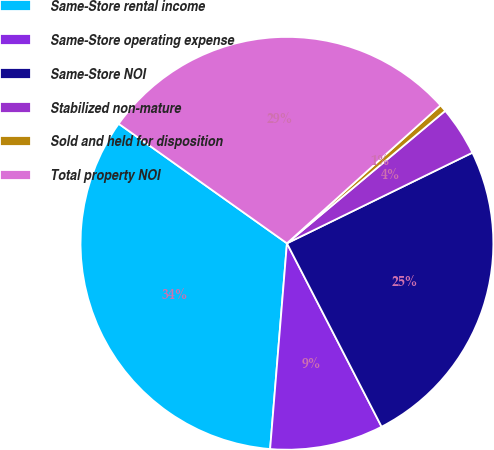Convert chart. <chart><loc_0><loc_0><loc_500><loc_500><pie_chart><fcel>Same-Store rental income<fcel>Same-Store operating expense<fcel>Same-Store NOI<fcel>Stabilized non-mature<fcel>Sold and held for disposition<fcel>Total property NOI<nl><fcel>33.53%<fcel>8.88%<fcel>24.65%<fcel>3.86%<fcel>0.56%<fcel>28.51%<nl></chart> 